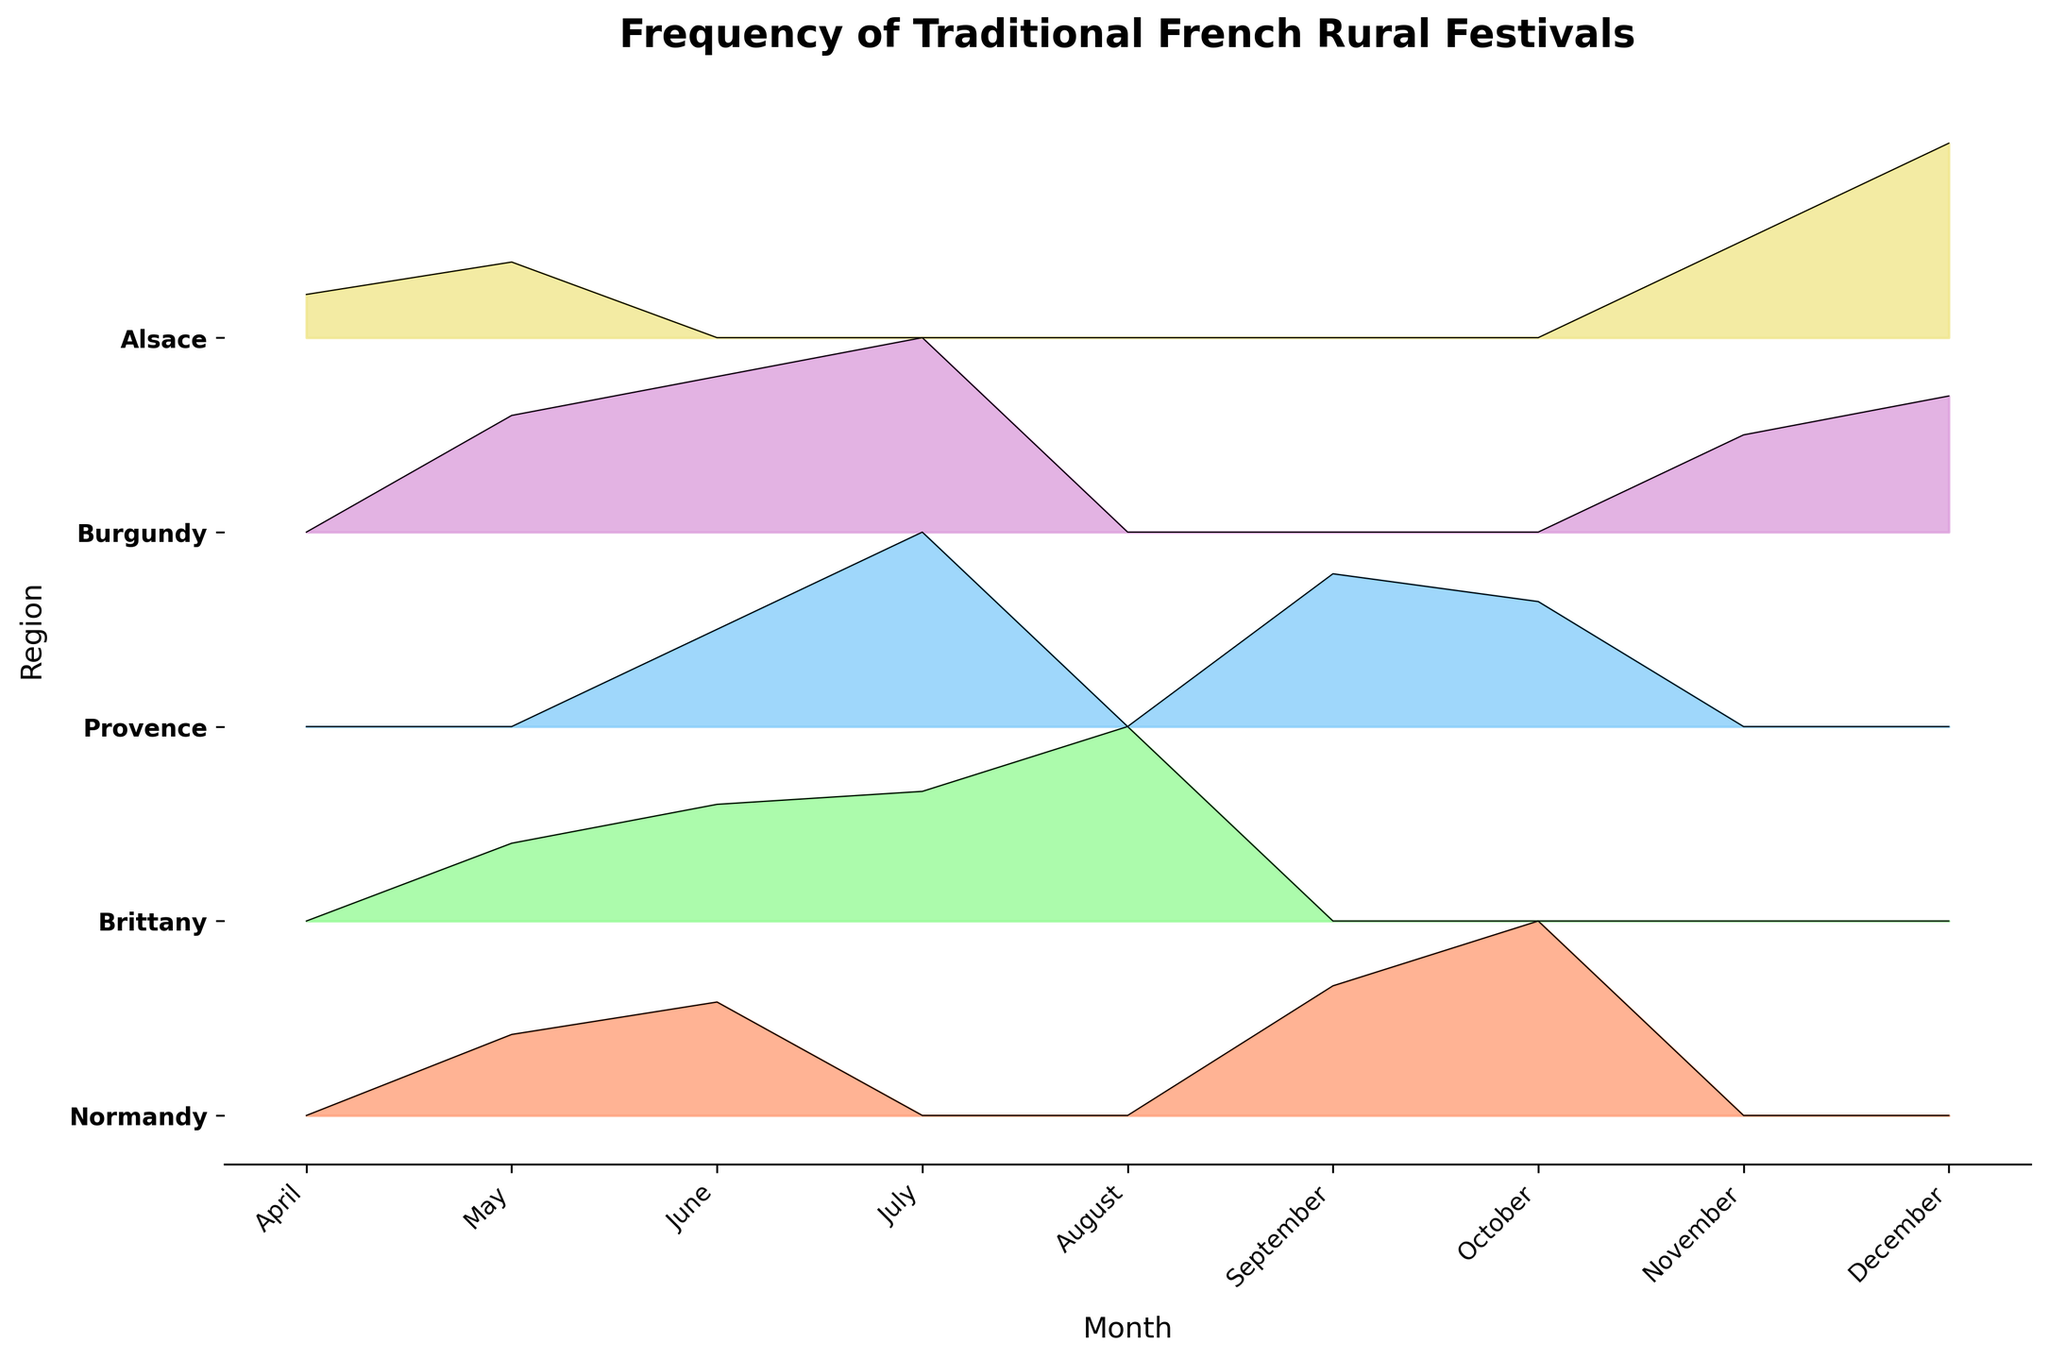What's the title of the plot? The title is located at the top of the plot and is meant to provide a summary of what the plot represents.
Answer: Frequency of Traditional French Rural Festivals Which region has the highest frequency of festivals in December? Look at the dataset and locate the December data points, identify the region with the highest value.
Answer: Alsace In which months does Normandy have festivals? Check the plot specifically for the area corresponding to Normandy and note the months indicated on the x-axis where there are frequencies greater than zero.
Answer: May, June, September, October How does the frequency of the Wine Harvest festivals in Provence compare between September and October? Locate Provence in the plot, and compare the height of the filled areas representing the Wine Harvest festival in September and October.
Answer: Higher in September Which festival type in Burgundy has the frequencies represented for the latest months in the year? Look at the plot’s x-axis towards the end of the year and find Burgundy’s color. Identify the corresponding festival.
Answer: Truffle Fair In which month does Brittany have the highest frequency of festivals? Look at the plot sections for Brittany and identify the month with the highest filled area.
Answer: August What's the maximum frequency of festivals in Alsace during December? Look at the highest point of the filled area for Alsace in December.
Answer: 18 Which region has the most consistent frequency of festivals over multiple months? Identify the region whose filled area heights do not vary drastically across multiple months, illustrating a more consistent pattern.
Answer: Normandy Are there any festivals in April? If so, which region hosts them? Check the x-axis for April, and see if there are any filled regions above zero level. Identify the corresponding region.
Answer: Alsace 